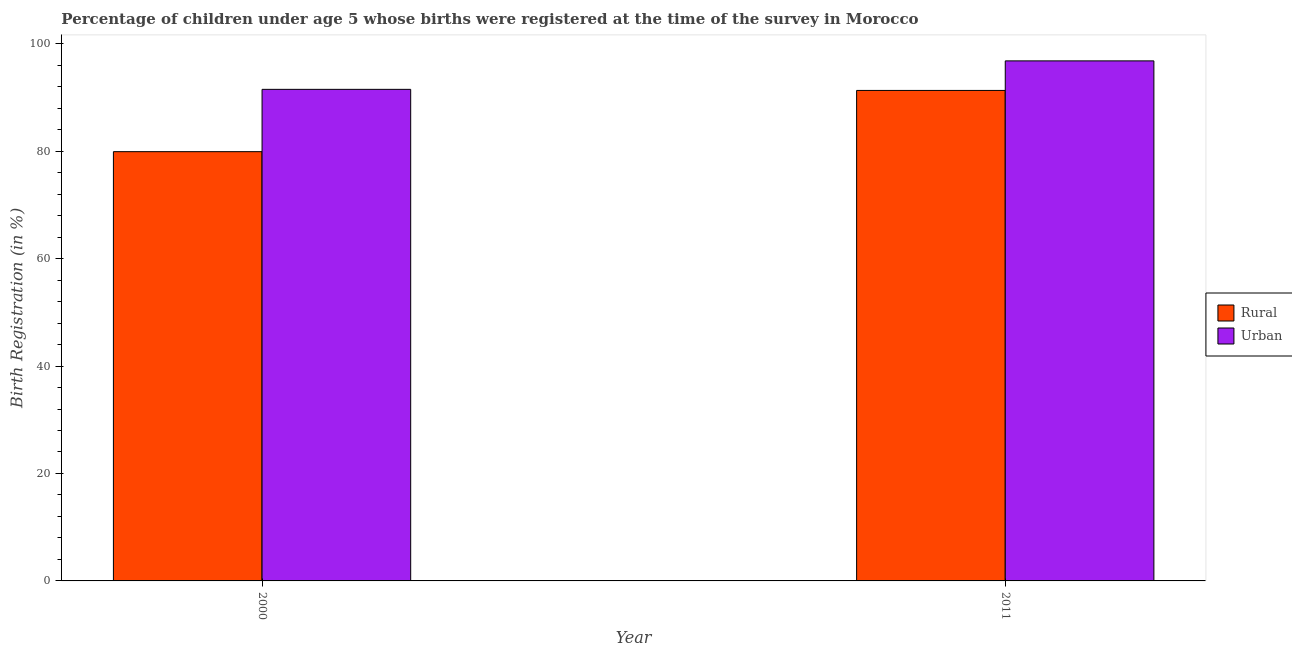Are the number of bars on each tick of the X-axis equal?
Offer a terse response. Yes. How many bars are there on the 2nd tick from the right?
Offer a very short reply. 2. What is the rural birth registration in 2000?
Make the answer very short. 79.9. Across all years, what is the maximum urban birth registration?
Your answer should be compact. 96.8. Across all years, what is the minimum urban birth registration?
Your answer should be compact. 91.5. In which year was the rural birth registration minimum?
Make the answer very short. 2000. What is the total rural birth registration in the graph?
Offer a terse response. 171.2. What is the difference between the urban birth registration in 2000 and that in 2011?
Offer a very short reply. -5.3. What is the difference between the rural birth registration in 2000 and the urban birth registration in 2011?
Offer a terse response. -11.4. What is the average rural birth registration per year?
Give a very brief answer. 85.6. What is the ratio of the rural birth registration in 2000 to that in 2011?
Provide a short and direct response. 0.88. What does the 2nd bar from the left in 2000 represents?
Your answer should be compact. Urban. What does the 2nd bar from the right in 2000 represents?
Keep it short and to the point. Rural. How many bars are there?
Give a very brief answer. 4. Are the values on the major ticks of Y-axis written in scientific E-notation?
Keep it short and to the point. No. Does the graph contain grids?
Keep it short and to the point. No. Where does the legend appear in the graph?
Ensure brevity in your answer.  Center right. What is the title of the graph?
Keep it short and to the point. Percentage of children under age 5 whose births were registered at the time of the survey in Morocco. What is the label or title of the X-axis?
Provide a succinct answer. Year. What is the label or title of the Y-axis?
Provide a short and direct response. Birth Registration (in %). What is the Birth Registration (in %) in Rural in 2000?
Provide a succinct answer. 79.9. What is the Birth Registration (in %) in Urban in 2000?
Make the answer very short. 91.5. What is the Birth Registration (in %) in Rural in 2011?
Your answer should be very brief. 91.3. What is the Birth Registration (in %) of Urban in 2011?
Provide a short and direct response. 96.8. Across all years, what is the maximum Birth Registration (in %) of Rural?
Your response must be concise. 91.3. Across all years, what is the maximum Birth Registration (in %) of Urban?
Your answer should be compact. 96.8. Across all years, what is the minimum Birth Registration (in %) in Rural?
Offer a terse response. 79.9. Across all years, what is the minimum Birth Registration (in %) in Urban?
Offer a very short reply. 91.5. What is the total Birth Registration (in %) of Rural in the graph?
Make the answer very short. 171.2. What is the total Birth Registration (in %) of Urban in the graph?
Offer a very short reply. 188.3. What is the difference between the Birth Registration (in %) in Rural in 2000 and that in 2011?
Your response must be concise. -11.4. What is the difference between the Birth Registration (in %) in Urban in 2000 and that in 2011?
Your answer should be very brief. -5.3. What is the difference between the Birth Registration (in %) in Rural in 2000 and the Birth Registration (in %) in Urban in 2011?
Your answer should be very brief. -16.9. What is the average Birth Registration (in %) in Rural per year?
Provide a short and direct response. 85.6. What is the average Birth Registration (in %) in Urban per year?
Offer a terse response. 94.15. What is the ratio of the Birth Registration (in %) of Rural in 2000 to that in 2011?
Give a very brief answer. 0.88. What is the ratio of the Birth Registration (in %) of Urban in 2000 to that in 2011?
Provide a short and direct response. 0.95. What is the difference between the highest and the second highest Birth Registration (in %) in Rural?
Provide a short and direct response. 11.4. What is the difference between the highest and the second highest Birth Registration (in %) of Urban?
Give a very brief answer. 5.3. What is the difference between the highest and the lowest Birth Registration (in %) of Rural?
Your response must be concise. 11.4. 